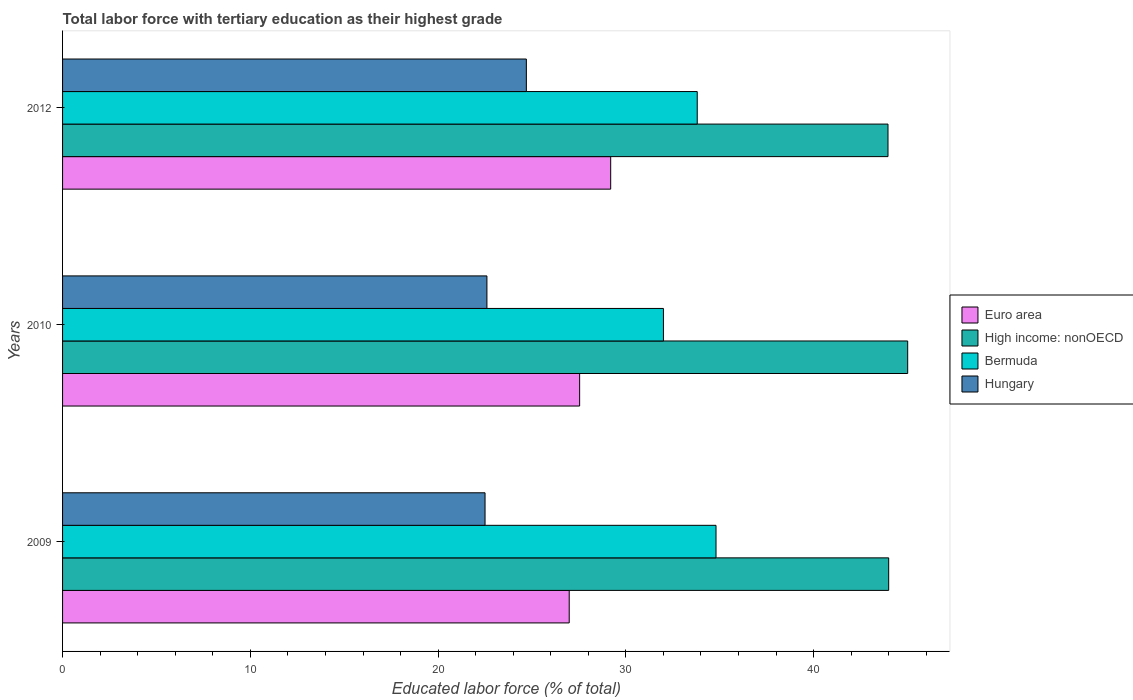How many different coloured bars are there?
Your answer should be compact. 4. How many groups of bars are there?
Provide a short and direct response. 3. Are the number of bars on each tick of the Y-axis equal?
Your response must be concise. Yes. What is the label of the 3rd group of bars from the top?
Give a very brief answer. 2009. What is the percentage of male labor force with tertiary education in Hungary in 2010?
Offer a very short reply. 22.6. Across all years, what is the maximum percentage of male labor force with tertiary education in Hungary?
Your answer should be compact. 24.7. Across all years, what is the minimum percentage of male labor force with tertiary education in Euro area?
Give a very brief answer. 26.98. In which year was the percentage of male labor force with tertiary education in High income: nonOECD maximum?
Keep it short and to the point. 2010. In which year was the percentage of male labor force with tertiary education in Euro area minimum?
Your answer should be very brief. 2009. What is the total percentage of male labor force with tertiary education in Euro area in the graph?
Offer a very short reply. 83.71. What is the difference between the percentage of male labor force with tertiary education in Euro area in 2009 and that in 2010?
Provide a succinct answer. -0.56. What is the difference between the percentage of male labor force with tertiary education in Bermuda in 2010 and the percentage of male labor force with tertiary education in Euro area in 2012?
Keep it short and to the point. 2.81. What is the average percentage of male labor force with tertiary education in Euro area per year?
Keep it short and to the point. 27.9. In the year 2012, what is the difference between the percentage of male labor force with tertiary education in Hungary and percentage of male labor force with tertiary education in Bermuda?
Ensure brevity in your answer.  -9.1. In how many years, is the percentage of male labor force with tertiary education in Hungary greater than 6 %?
Provide a succinct answer. 3. What is the ratio of the percentage of male labor force with tertiary education in Euro area in 2010 to that in 2012?
Give a very brief answer. 0.94. Is the percentage of male labor force with tertiary education in Bermuda in 2010 less than that in 2012?
Your answer should be very brief. Yes. Is the difference between the percentage of male labor force with tertiary education in Hungary in 2009 and 2010 greater than the difference between the percentage of male labor force with tertiary education in Bermuda in 2009 and 2010?
Offer a terse response. No. What is the difference between the highest and the second highest percentage of male labor force with tertiary education in Bermuda?
Keep it short and to the point. 1. What is the difference between the highest and the lowest percentage of male labor force with tertiary education in Euro area?
Your answer should be compact. 2.21. In how many years, is the percentage of male labor force with tertiary education in Euro area greater than the average percentage of male labor force with tertiary education in Euro area taken over all years?
Your response must be concise. 1. Is it the case that in every year, the sum of the percentage of male labor force with tertiary education in Euro area and percentage of male labor force with tertiary education in High income: nonOECD is greater than the sum of percentage of male labor force with tertiary education in Hungary and percentage of male labor force with tertiary education in Bermuda?
Ensure brevity in your answer.  Yes. What does the 2nd bar from the top in 2009 represents?
Offer a very short reply. Bermuda. What does the 1st bar from the bottom in 2010 represents?
Make the answer very short. Euro area. How many years are there in the graph?
Offer a very short reply. 3. What is the difference between two consecutive major ticks on the X-axis?
Your response must be concise. 10. Does the graph contain any zero values?
Keep it short and to the point. No. What is the title of the graph?
Your answer should be compact. Total labor force with tertiary education as their highest grade. What is the label or title of the X-axis?
Offer a terse response. Educated labor force (% of total). What is the Educated labor force (% of total) in Euro area in 2009?
Offer a very short reply. 26.98. What is the Educated labor force (% of total) of High income: nonOECD in 2009?
Make the answer very short. 44. What is the Educated labor force (% of total) of Bermuda in 2009?
Give a very brief answer. 34.8. What is the Educated labor force (% of total) in Hungary in 2009?
Keep it short and to the point. 22.5. What is the Educated labor force (% of total) of Euro area in 2010?
Your response must be concise. 27.54. What is the Educated labor force (% of total) in High income: nonOECD in 2010?
Your answer should be compact. 45.01. What is the Educated labor force (% of total) in Bermuda in 2010?
Keep it short and to the point. 32. What is the Educated labor force (% of total) in Hungary in 2010?
Offer a terse response. 22.6. What is the Educated labor force (% of total) in Euro area in 2012?
Offer a very short reply. 29.19. What is the Educated labor force (% of total) of High income: nonOECD in 2012?
Your answer should be very brief. 43.96. What is the Educated labor force (% of total) of Bermuda in 2012?
Keep it short and to the point. 33.8. What is the Educated labor force (% of total) in Hungary in 2012?
Offer a very short reply. 24.7. Across all years, what is the maximum Educated labor force (% of total) in Euro area?
Keep it short and to the point. 29.19. Across all years, what is the maximum Educated labor force (% of total) of High income: nonOECD?
Your answer should be compact. 45.01. Across all years, what is the maximum Educated labor force (% of total) in Bermuda?
Offer a terse response. 34.8. Across all years, what is the maximum Educated labor force (% of total) of Hungary?
Your answer should be compact. 24.7. Across all years, what is the minimum Educated labor force (% of total) of Euro area?
Provide a short and direct response. 26.98. Across all years, what is the minimum Educated labor force (% of total) of High income: nonOECD?
Your answer should be compact. 43.96. What is the total Educated labor force (% of total) in Euro area in the graph?
Your response must be concise. 83.71. What is the total Educated labor force (% of total) in High income: nonOECD in the graph?
Provide a succinct answer. 132.96. What is the total Educated labor force (% of total) of Bermuda in the graph?
Offer a very short reply. 100.6. What is the total Educated labor force (% of total) in Hungary in the graph?
Make the answer very short. 69.8. What is the difference between the Educated labor force (% of total) of Euro area in 2009 and that in 2010?
Provide a short and direct response. -0.56. What is the difference between the Educated labor force (% of total) of High income: nonOECD in 2009 and that in 2010?
Provide a short and direct response. -1.01. What is the difference between the Educated labor force (% of total) in Bermuda in 2009 and that in 2010?
Offer a very short reply. 2.8. What is the difference between the Educated labor force (% of total) of Hungary in 2009 and that in 2010?
Keep it short and to the point. -0.1. What is the difference between the Educated labor force (% of total) in Euro area in 2009 and that in 2012?
Offer a very short reply. -2.21. What is the difference between the Educated labor force (% of total) in High income: nonOECD in 2009 and that in 2012?
Offer a very short reply. 0.04. What is the difference between the Educated labor force (% of total) in Hungary in 2009 and that in 2012?
Your answer should be very brief. -2.2. What is the difference between the Educated labor force (% of total) in Euro area in 2010 and that in 2012?
Keep it short and to the point. -1.65. What is the difference between the Educated labor force (% of total) of High income: nonOECD in 2010 and that in 2012?
Provide a short and direct response. 1.05. What is the difference between the Educated labor force (% of total) in Bermuda in 2010 and that in 2012?
Your answer should be very brief. -1.8. What is the difference between the Educated labor force (% of total) in Euro area in 2009 and the Educated labor force (% of total) in High income: nonOECD in 2010?
Provide a short and direct response. -18.03. What is the difference between the Educated labor force (% of total) of Euro area in 2009 and the Educated labor force (% of total) of Bermuda in 2010?
Provide a short and direct response. -5.02. What is the difference between the Educated labor force (% of total) of Euro area in 2009 and the Educated labor force (% of total) of Hungary in 2010?
Make the answer very short. 4.38. What is the difference between the Educated labor force (% of total) in High income: nonOECD in 2009 and the Educated labor force (% of total) in Bermuda in 2010?
Provide a short and direct response. 12. What is the difference between the Educated labor force (% of total) of High income: nonOECD in 2009 and the Educated labor force (% of total) of Hungary in 2010?
Your answer should be very brief. 21.4. What is the difference between the Educated labor force (% of total) in Euro area in 2009 and the Educated labor force (% of total) in High income: nonOECD in 2012?
Ensure brevity in your answer.  -16.98. What is the difference between the Educated labor force (% of total) of Euro area in 2009 and the Educated labor force (% of total) of Bermuda in 2012?
Your answer should be compact. -6.82. What is the difference between the Educated labor force (% of total) in Euro area in 2009 and the Educated labor force (% of total) in Hungary in 2012?
Provide a short and direct response. 2.28. What is the difference between the Educated labor force (% of total) in High income: nonOECD in 2009 and the Educated labor force (% of total) in Bermuda in 2012?
Give a very brief answer. 10.2. What is the difference between the Educated labor force (% of total) of High income: nonOECD in 2009 and the Educated labor force (% of total) of Hungary in 2012?
Your answer should be compact. 19.3. What is the difference between the Educated labor force (% of total) of Bermuda in 2009 and the Educated labor force (% of total) of Hungary in 2012?
Your response must be concise. 10.1. What is the difference between the Educated labor force (% of total) in Euro area in 2010 and the Educated labor force (% of total) in High income: nonOECD in 2012?
Provide a short and direct response. -16.42. What is the difference between the Educated labor force (% of total) of Euro area in 2010 and the Educated labor force (% of total) of Bermuda in 2012?
Provide a succinct answer. -6.26. What is the difference between the Educated labor force (% of total) of Euro area in 2010 and the Educated labor force (% of total) of Hungary in 2012?
Keep it short and to the point. 2.84. What is the difference between the Educated labor force (% of total) of High income: nonOECD in 2010 and the Educated labor force (% of total) of Bermuda in 2012?
Your response must be concise. 11.21. What is the difference between the Educated labor force (% of total) in High income: nonOECD in 2010 and the Educated labor force (% of total) in Hungary in 2012?
Provide a succinct answer. 20.31. What is the difference between the Educated labor force (% of total) in Bermuda in 2010 and the Educated labor force (% of total) in Hungary in 2012?
Provide a short and direct response. 7.3. What is the average Educated labor force (% of total) of Euro area per year?
Ensure brevity in your answer.  27.9. What is the average Educated labor force (% of total) of High income: nonOECD per year?
Make the answer very short. 44.32. What is the average Educated labor force (% of total) of Bermuda per year?
Your answer should be very brief. 33.53. What is the average Educated labor force (% of total) in Hungary per year?
Give a very brief answer. 23.27. In the year 2009, what is the difference between the Educated labor force (% of total) of Euro area and Educated labor force (% of total) of High income: nonOECD?
Provide a succinct answer. -17.01. In the year 2009, what is the difference between the Educated labor force (% of total) in Euro area and Educated labor force (% of total) in Bermuda?
Ensure brevity in your answer.  -7.82. In the year 2009, what is the difference between the Educated labor force (% of total) of Euro area and Educated labor force (% of total) of Hungary?
Give a very brief answer. 4.48. In the year 2009, what is the difference between the Educated labor force (% of total) in High income: nonOECD and Educated labor force (% of total) in Bermuda?
Give a very brief answer. 9.2. In the year 2009, what is the difference between the Educated labor force (% of total) in High income: nonOECD and Educated labor force (% of total) in Hungary?
Ensure brevity in your answer.  21.5. In the year 2010, what is the difference between the Educated labor force (% of total) of Euro area and Educated labor force (% of total) of High income: nonOECD?
Offer a terse response. -17.47. In the year 2010, what is the difference between the Educated labor force (% of total) of Euro area and Educated labor force (% of total) of Bermuda?
Provide a short and direct response. -4.46. In the year 2010, what is the difference between the Educated labor force (% of total) of Euro area and Educated labor force (% of total) of Hungary?
Make the answer very short. 4.94. In the year 2010, what is the difference between the Educated labor force (% of total) of High income: nonOECD and Educated labor force (% of total) of Bermuda?
Offer a very short reply. 13.01. In the year 2010, what is the difference between the Educated labor force (% of total) of High income: nonOECD and Educated labor force (% of total) of Hungary?
Make the answer very short. 22.41. In the year 2010, what is the difference between the Educated labor force (% of total) of Bermuda and Educated labor force (% of total) of Hungary?
Provide a short and direct response. 9.4. In the year 2012, what is the difference between the Educated labor force (% of total) in Euro area and Educated labor force (% of total) in High income: nonOECD?
Ensure brevity in your answer.  -14.77. In the year 2012, what is the difference between the Educated labor force (% of total) of Euro area and Educated labor force (% of total) of Bermuda?
Provide a short and direct response. -4.61. In the year 2012, what is the difference between the Educated labor force (% of total) of Euro area and Educated labor force (% of total) of Hungary?
Give a very brief answer. 4.49. In the year 2012, what is the difference between the Educated labor force (% of total) in High income: nonOECD and Educated labor force (% of total) in Bermuda?
Offer a terse response. 10.16. In the year 2012, what is the difference between the Educated labor force (% of total) in High income: nonOECD and Educated labor force (% of total) in Hungary?
Provide a succinct answer. 19.26. In the year 2012, what is the difference between the Educated labor force (% of total) in Bermuda and Educated labor force (% of total) in Hungary?
Keep it short and to the point. 9.1. What is the ratio of the Educated labor force (% of total) of Euro area in 2009 to that in 2010?
Your answer should be compact. 0.98. What is the ratio of the Educated labor force (% of total) in High income: nonOECD in 2009 to that in 2010?
Your response must be concise. 0.98. What is the ratio of the Educated labor force (% of total) in Bermuda in 2009 to that in 2010?
Give a very brief answer. 1.09. What is the ratio of the Educated labor force (% of total) of Euro area in 2009 to that in 2012?
Ensure brevity in your answer.  0.92. What is the ratio of the Educated labor force (% of total) in Bermuda in 2009 to that in 2012?
Offer a terse response. 1.03. What is the ratio of the Educated labor force (% of total) in Hungary in 2009 to that in 2012?
Your response must be concise. 0.91. What is the ratio of the Educated labor force (% of total) in Euro area in 2010 to that in 2012?
Make the answer very short. 0.94. What is the ratio of the Educated labor force (% of total) in High income: nonOECD in 2010 to that in 2012?
Keep it short and to the point. 1.02. What is the ratio of the Educated labor force (% of total) of Bermuda in 2010 to that in 2012?
Make the answer very short. 0.95. What is the ratio of the Educated labor force (% of total) of Hungary in 2010 to that in 2012?
Your answer should be very brief. 0.92. What is the difference between the highest and the second highest Educated labor force (% of total) of Euro area?
Make the answer very short. 1.65. What is the difference between the highest and the second highest Educated labor force (% of total) of High income: nonOECD?
Ensure brevity in your answer.  1.01. What is the difference between the highest and the lowest Educated labor force (% of total) in Euro area?
Your answer should be compact. 2.21. What is the difference between the highest and the lowest Educated labor force (% of total) in High income: nonOECD?
Your answer should be compact. 1.05. What is the difference between the highest and the lowest Educated labor force (% of total) in Bermuda?
Give a very brief answer. 2.8. 